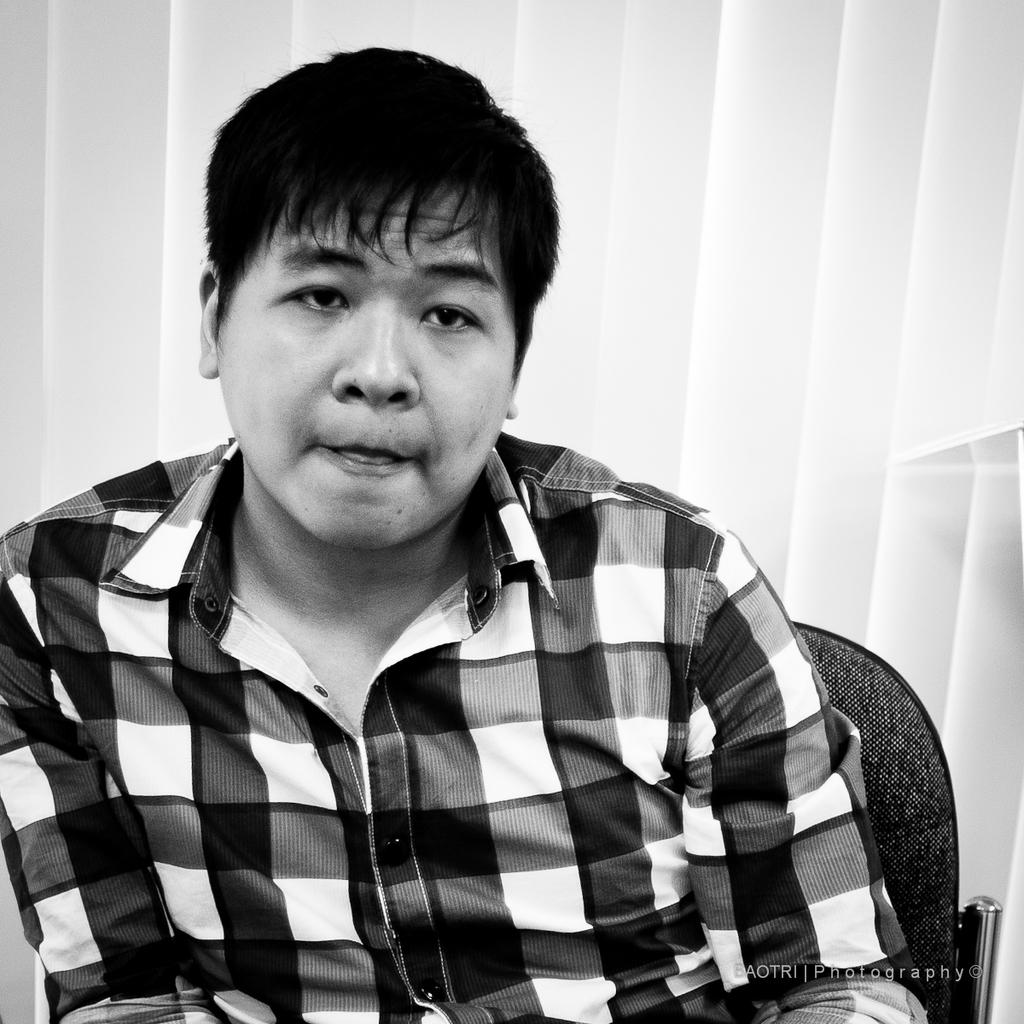What is the main subject of the image? There is a person in the image. What is the person doing in the image? The person is sitting on a chair. Where is the chair located in the image? The chair is in the center of the image. What news is the person reading in the image? There is no news or any reading material visible in the image. 